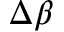Convert formula to latex. <formula><loc_0><loc_0><loc_500><loc_500>\Delta \beta</formula> 